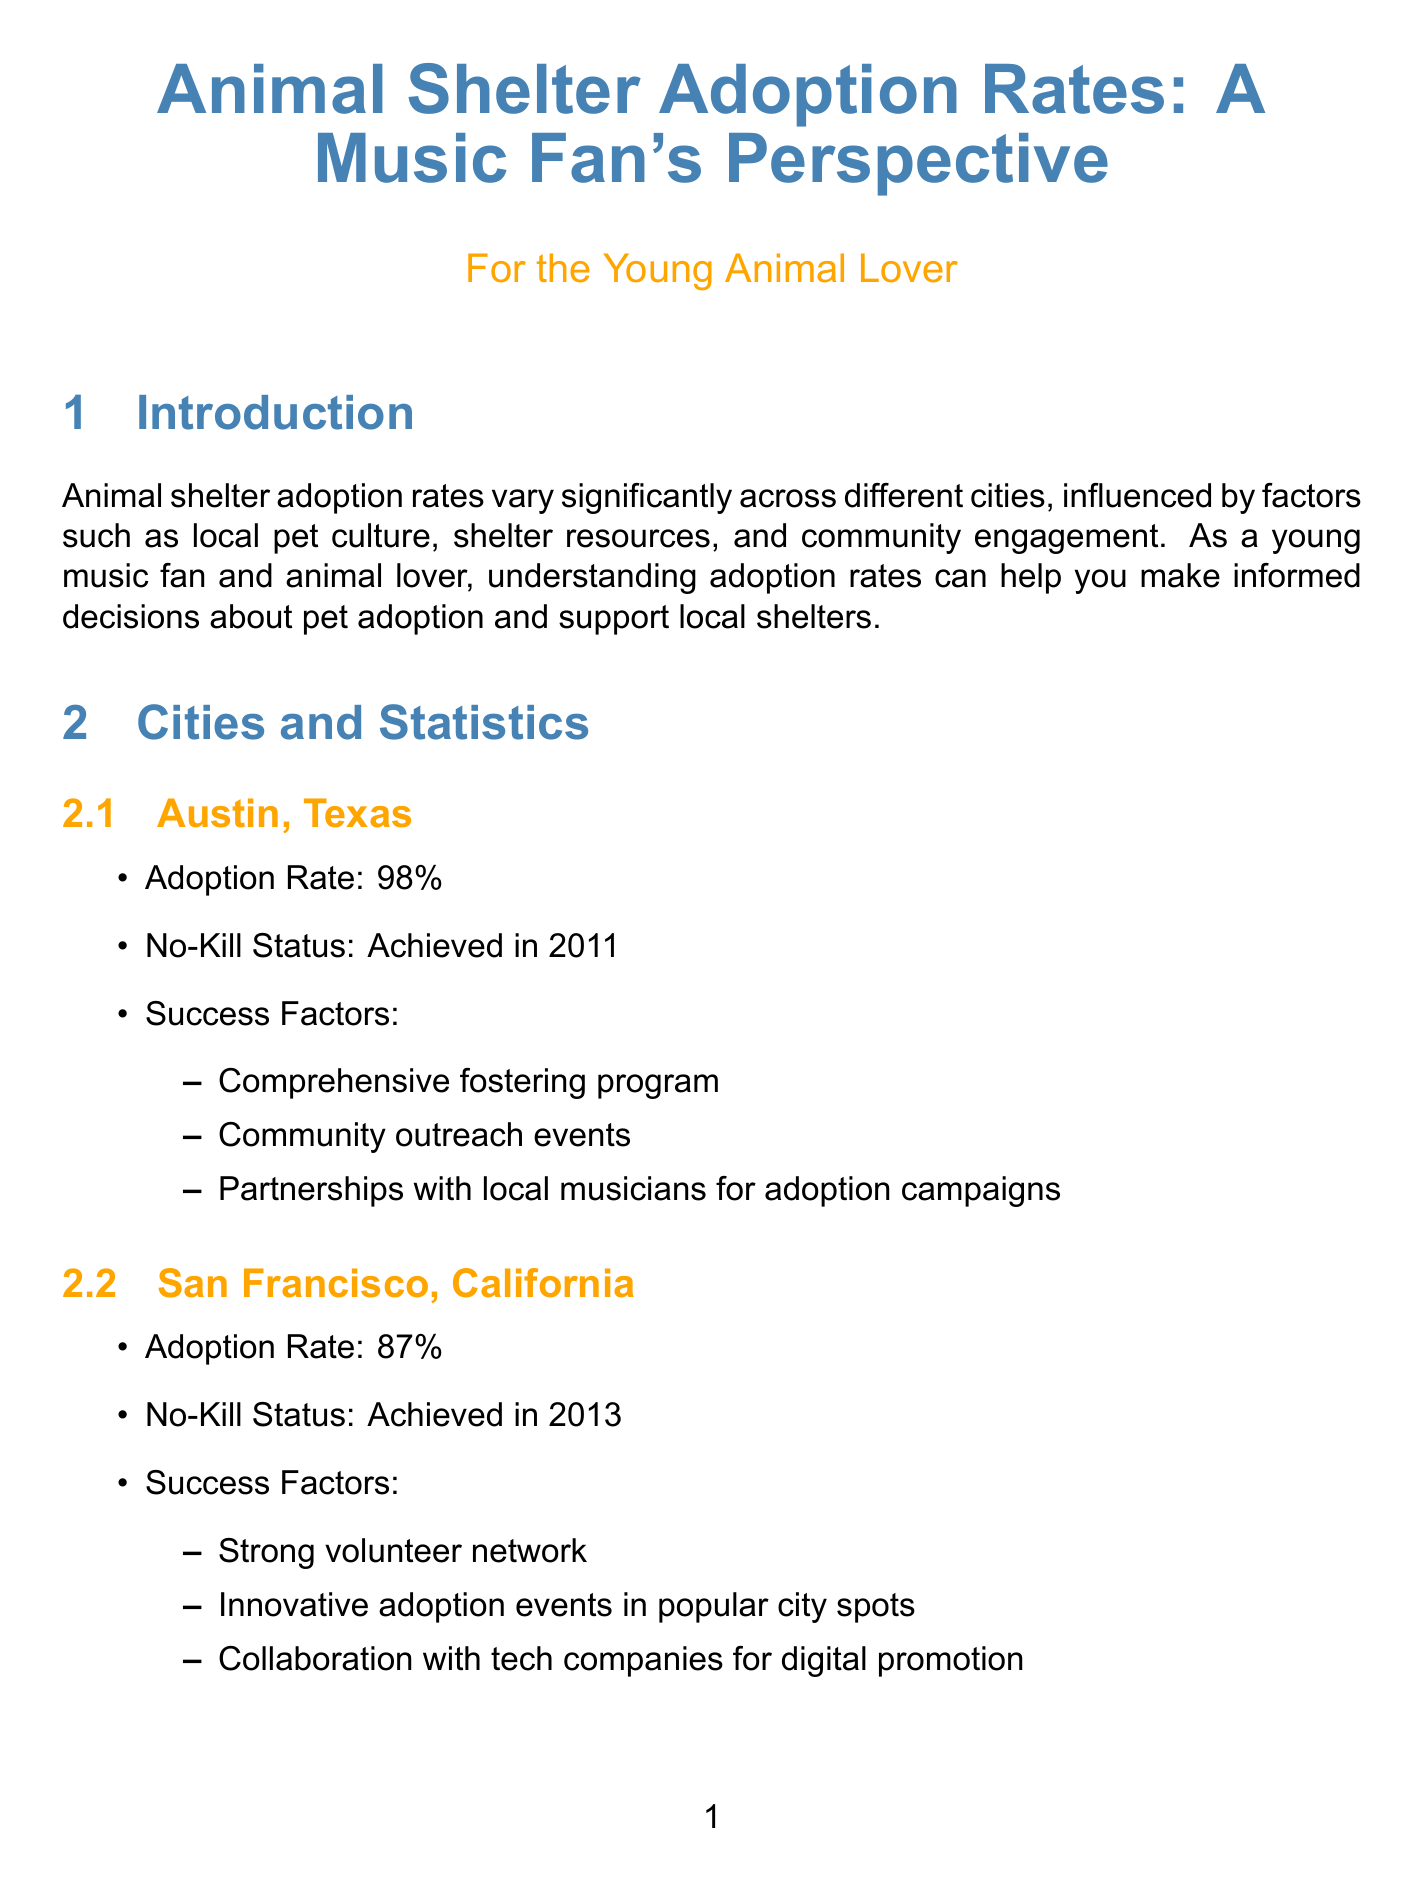What is the adoption rate in Austin, Texas? The adoption rate in Austin, Texas is stated in the document as 98%.
Answer: 98% What year did Austin achieve no-kill status? The document specifies that Austin achieved no-kill status in 2011.
Answer: 2011 What is one factor contributing to adoption success in San Francisco? The document lists several success factors, one of which is a strong volunteer network.
Answer: Strong volunteer network Which city has a success story involving a three-legged dog? The document highlights a success story about Bella, a three-legged dog, in Austin.
Answer: Austin What innovative strategy involves local music festivals? The document mentions "Music festival adoption booths" as an innovative strategy for adoption.
Answer: Music festival adoption booths Which shelter is associated with the success story of the cat named Whiskers? The document indicates that Whiskers is associated with the San Francisco SPCA.
Answer: San Francisco SPCA What is one challenge faced by urban shelters? The document identifies "Overcrowding in urban shelters" as a challenge that shelters face.
Answer: Overcrowding in urban shelters What is the purpose of foster-to-adopt programs? The document explains that foster-to-adopt programs allow potential adopters to foster animals before making a final decision.
Answer: Foster animals before final decision 